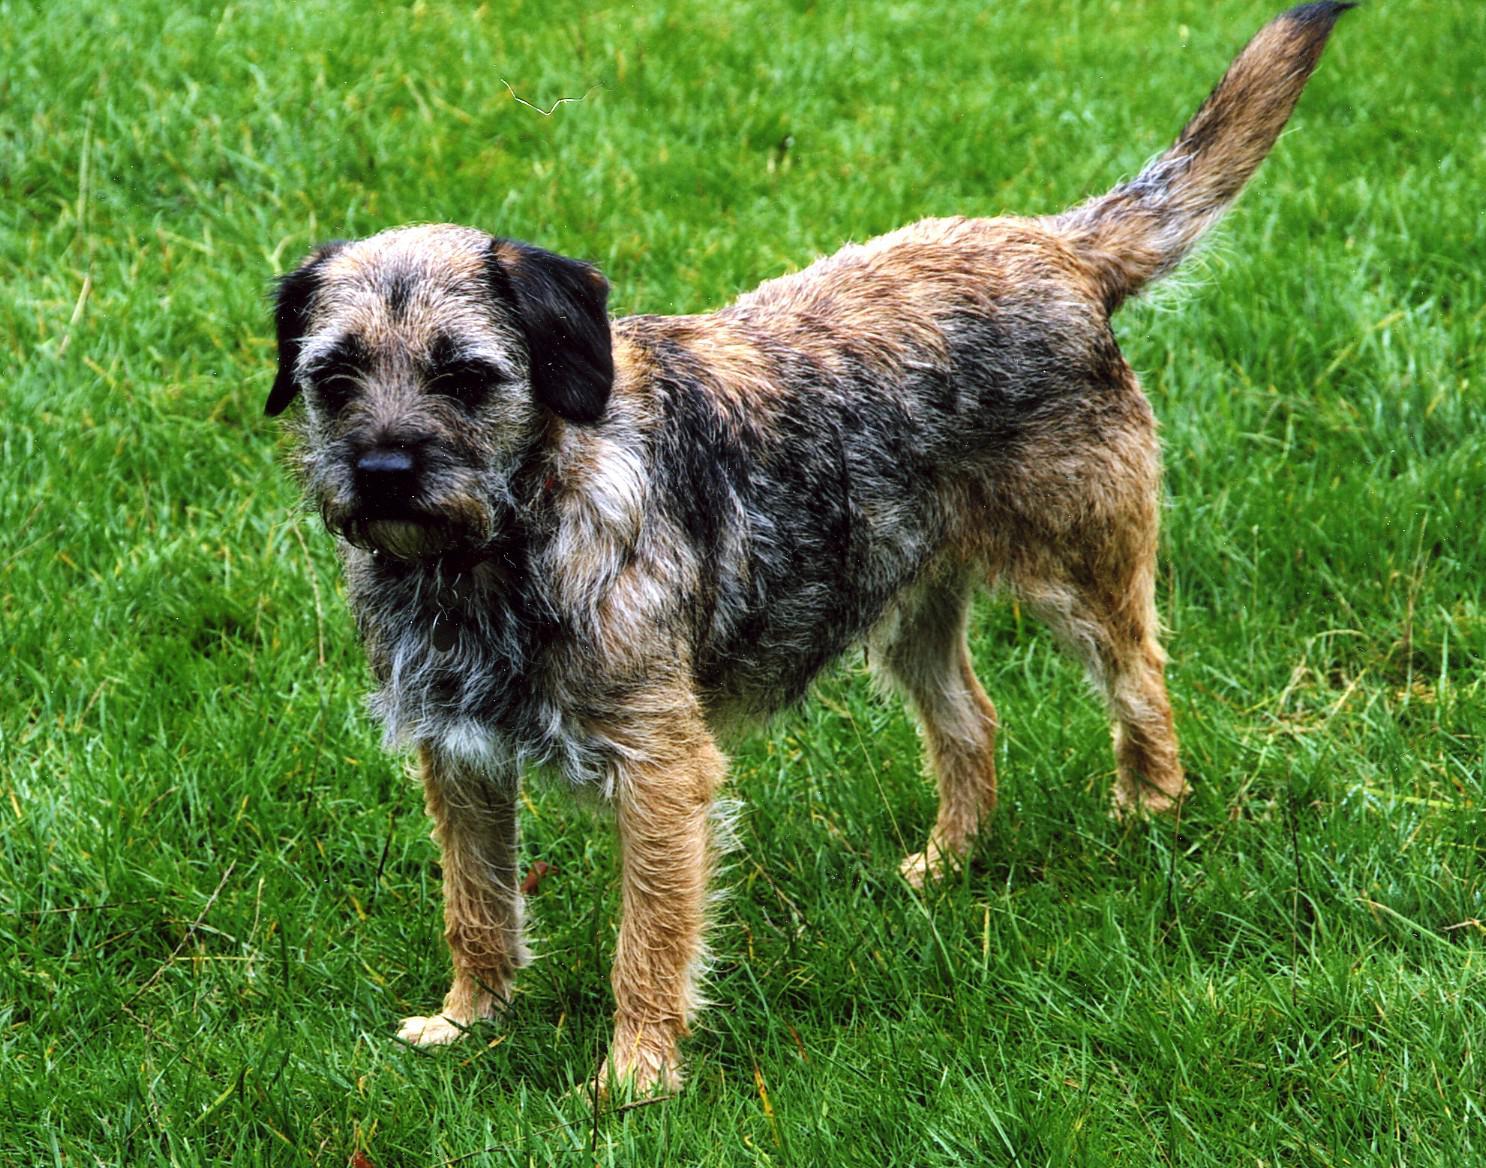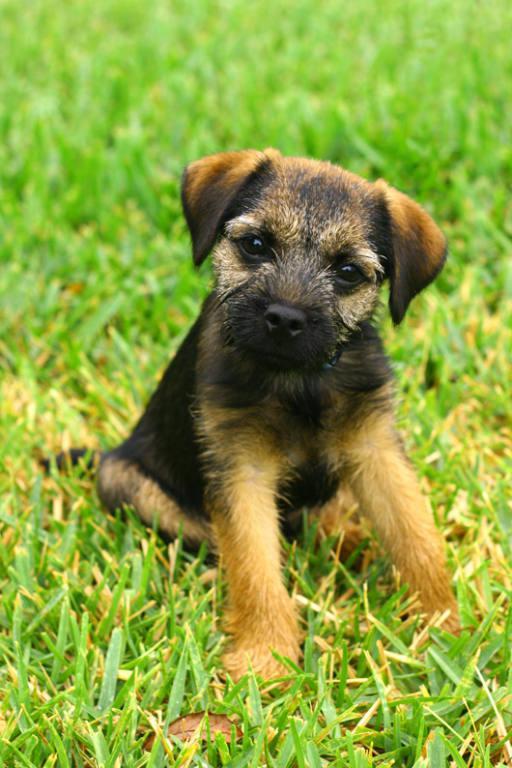The first image is the image on the left, the second image is the image on the right. Examine the images to the left and right. Is the description "The left image shows a dog standing with all four paws on the ground." accurate? Answer yes or no. Yes. 